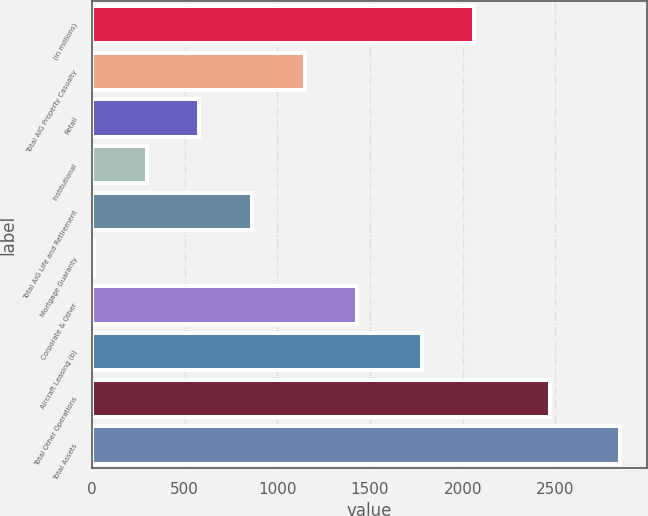Convert chart. <chart><loc_0><loc_0><loc_500><loc_500><bar_chart><fcel>(in millions)<fcel>Total AIG Property Casualty<fcel>Retail<fcel>Institutional<fcel>Total AIG Life and Retirement<fcel>Mortgage Guaranty<fcel>Corporate & Other<fcel>Aircraft Leasing (b)<fcel>Total Other Operations<fcel>Total Assets<nl><fcel>2063<fcel>1147<fcel>579<fcel>295<fcel>863<fcel>11<fcel>1431<fcel>1779<fcel>2470<fcel>2851<nl></chart> 